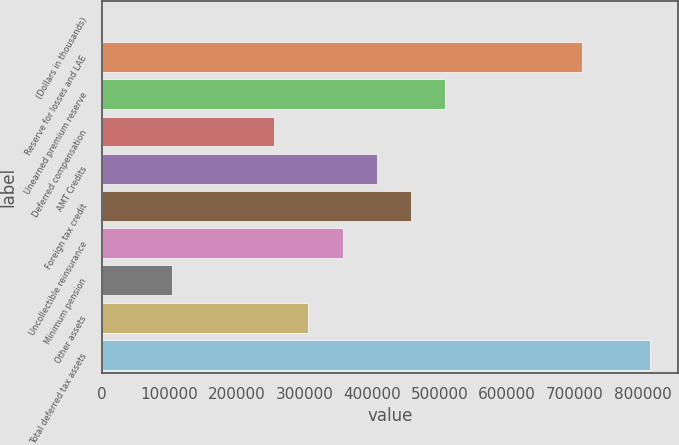Convert chart. <chart><loc_0><loc_0><loc_500><loc_500><bar_chart><fcel>(Dollars in thousands)<fcel>Reserve for losses and LAE<fcel>Unearned premium reserve<fcel>Deferred compensation<fcel>AMT Credits<fcel>Foreign tax credit<fcel>Uncollectible reinsurance<fcel>Minimum pension<fcel>Other assets<fcel>Total deferred tax assets<nl><fcel>2006<fcel>710225<fcel>507877<fcel>254942<fcel>406703<fcel>457290<fcel>356116<fcel>103180<fcel>305529<fcel>811400<nl></chart> 